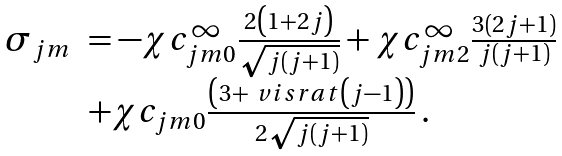<formula> <loc_0><loc_0><loc_500><loc_500>\begin{array} { l l } \sigma _ { j m } & = - \chi c ^ { \infty } _ { j m 0 } \frac { 2 \left ( 1 + 2 j \right ) } { \sqrt { j ( j + 1 ) } } + \chi c ^ { \infty } _ { j m 2 } \frac { 3 ( 2 j + 1 ) } { j ( j + 1 ) } \\ & + \chi c _ { j m 0 } \frac { \left ( 3 + \ v i s r a t \left ( j - 1 \right ) \right ) } { 2 \sqrt { j ( j + 1 ) } } \, . \end{array}</formula> 